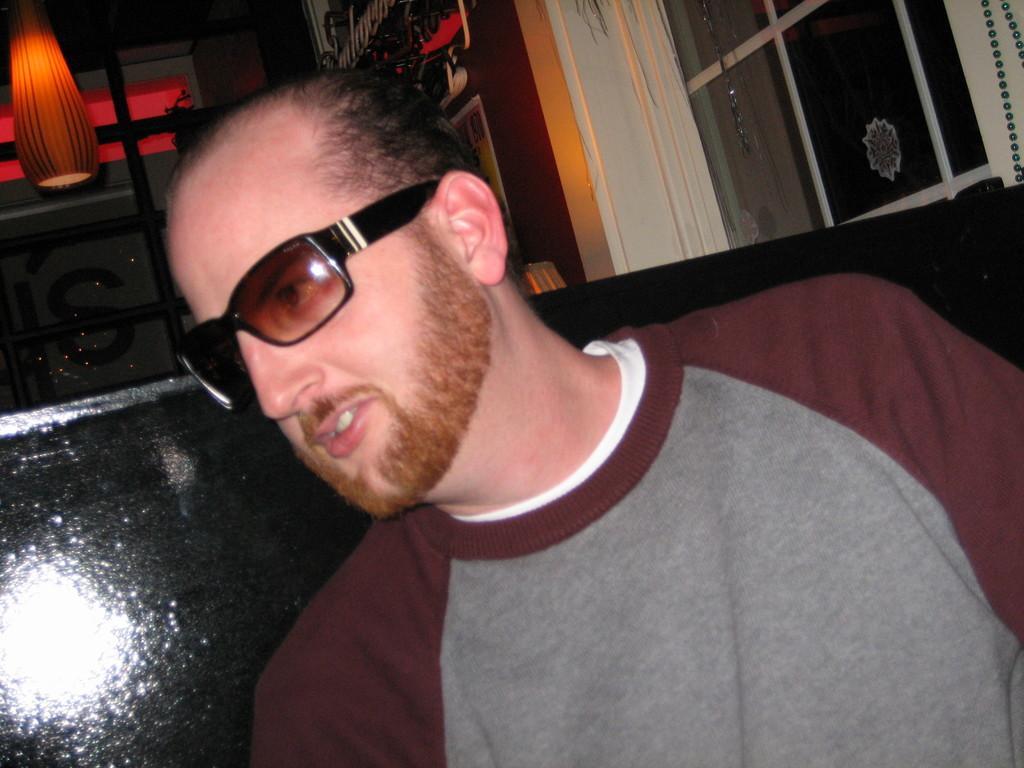In one or two sentences, can you explain what this image depicts? In the image I can see a person who is wearing the spectacles and behind there is a lamp. 